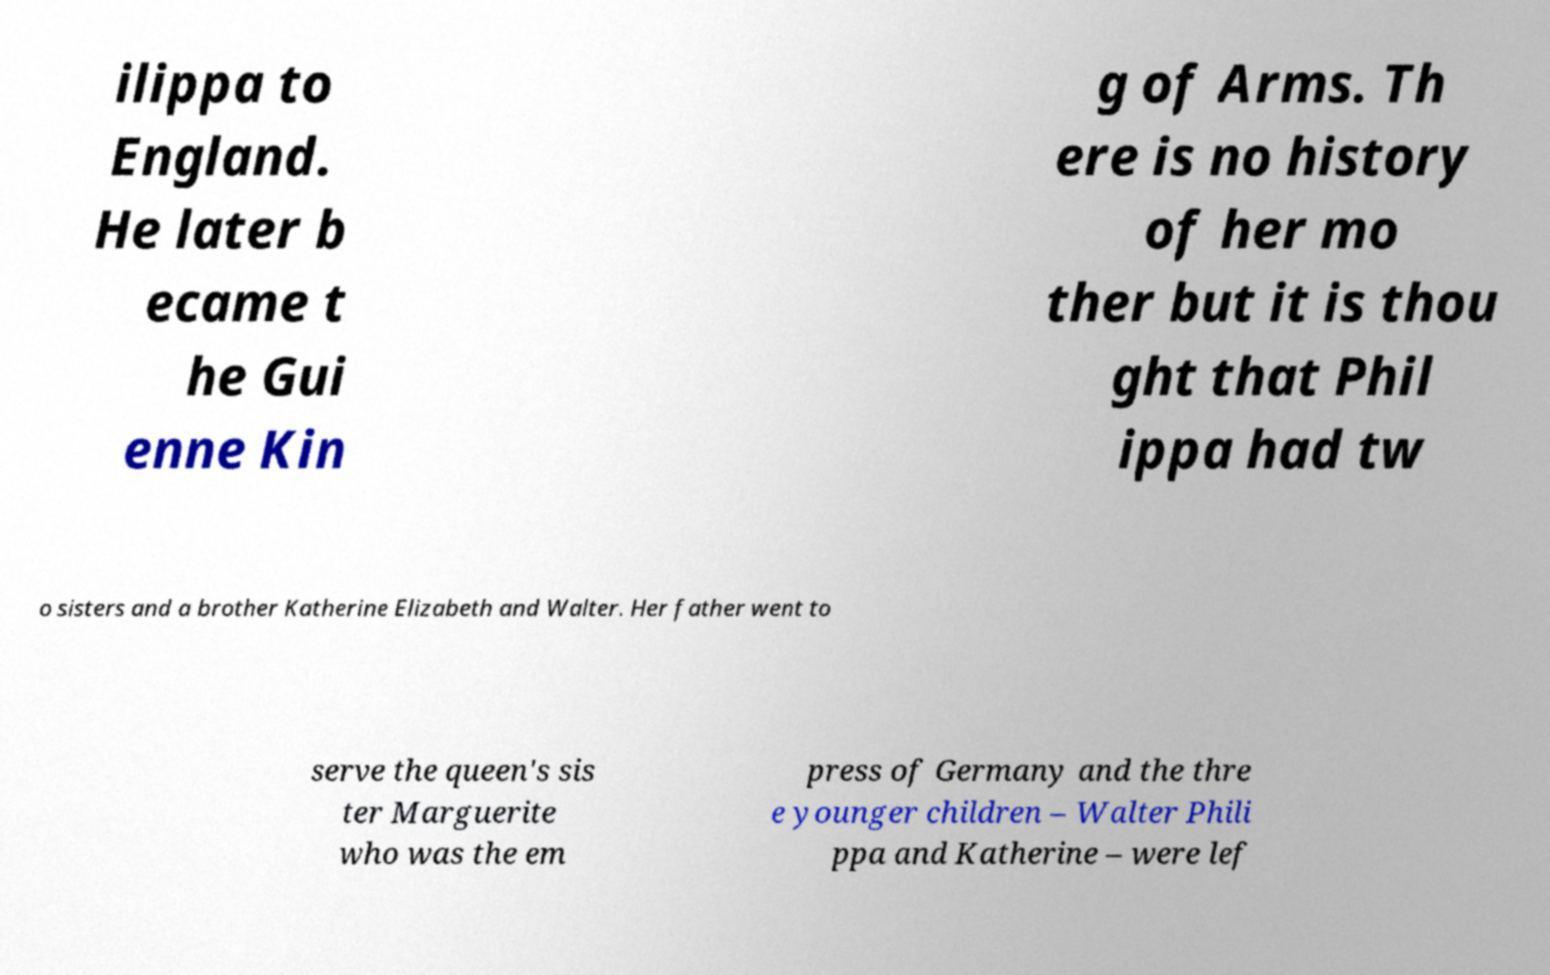There's text embedded in this image that I need extracted. Can you transcribe it verbatim? ilippa to England. He later b ecame t he Gui enne Kin g of Arms. Th ere is no history of her mo ther but it is thou ght that Phil ippa had tw o sisters and a brother Katherine Elizabeth and Walter. Her father went to serve the queen's sis ter Marguerite who was the em press of Germany and the thre e younger children – Walter Phili ppa and Katherine – were lef 